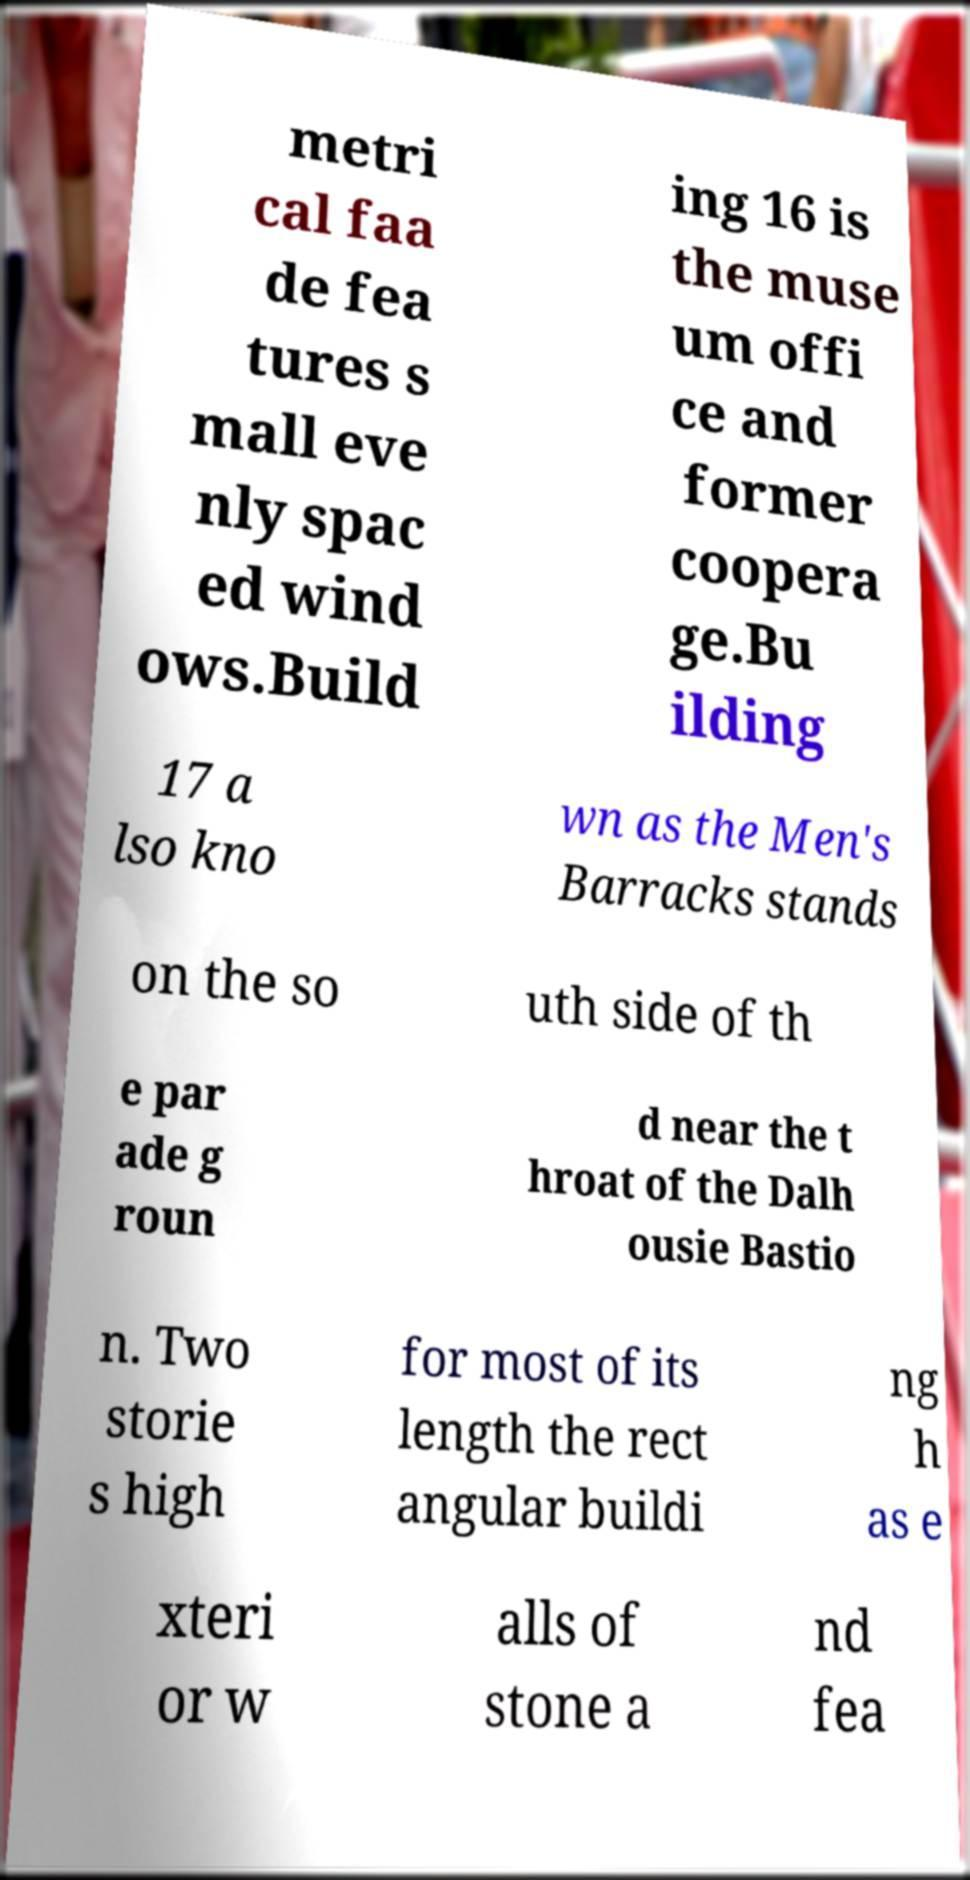I need the written content from this picture converted into text. Can you do that? metri cal faa de fea tures s mall eve nly spac ed wind ows.Build ing 16 is the muse um offi ce and former coopera ge.Bu ilding 17 a lso kno wn as the Men's Barracks stands on the so uth side of th e par ade g roun d near the t hroat of the Dalh ousie Bastio n. Two storie s high for most of its length the rect angular buildi ng h as e xteri or w alls of stone a nd fea 